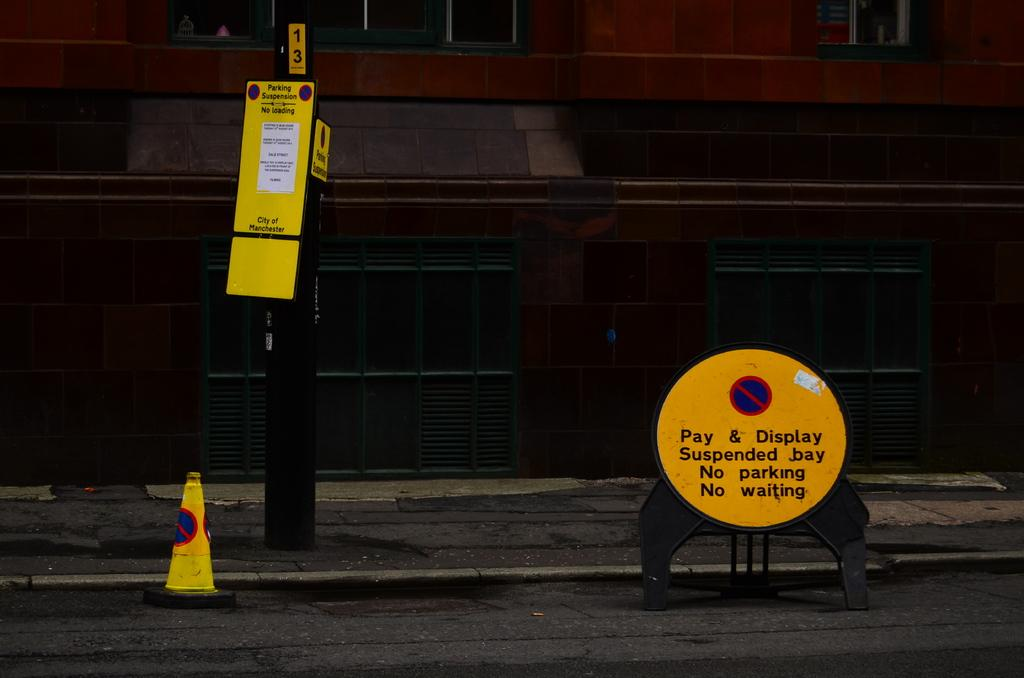What can be seen in the image that indicates the presence of names or labels? There are name boards in the image. What structures are visible in the image that might be used for support or signage? There are poles in the image. What is the black object on the road in the image? There is a black color object on the road, but it is not specified what it is. What safety feature is present in the image? There is a traffic cone in the image. What type of pathway is visible in the image? There is a walkway in the image. What can be seen in the background of the image that might be part of a building or structure? There is a wall in the background of the image. What type of objects are visible in the background of the image that might be made of glass? There are glass objects in the background of the image. Is there a border crossing visible in the image? No, there is no border crossing visible in the image. Is there a jail in the background of the image? No, there is no jail visible in the image. 